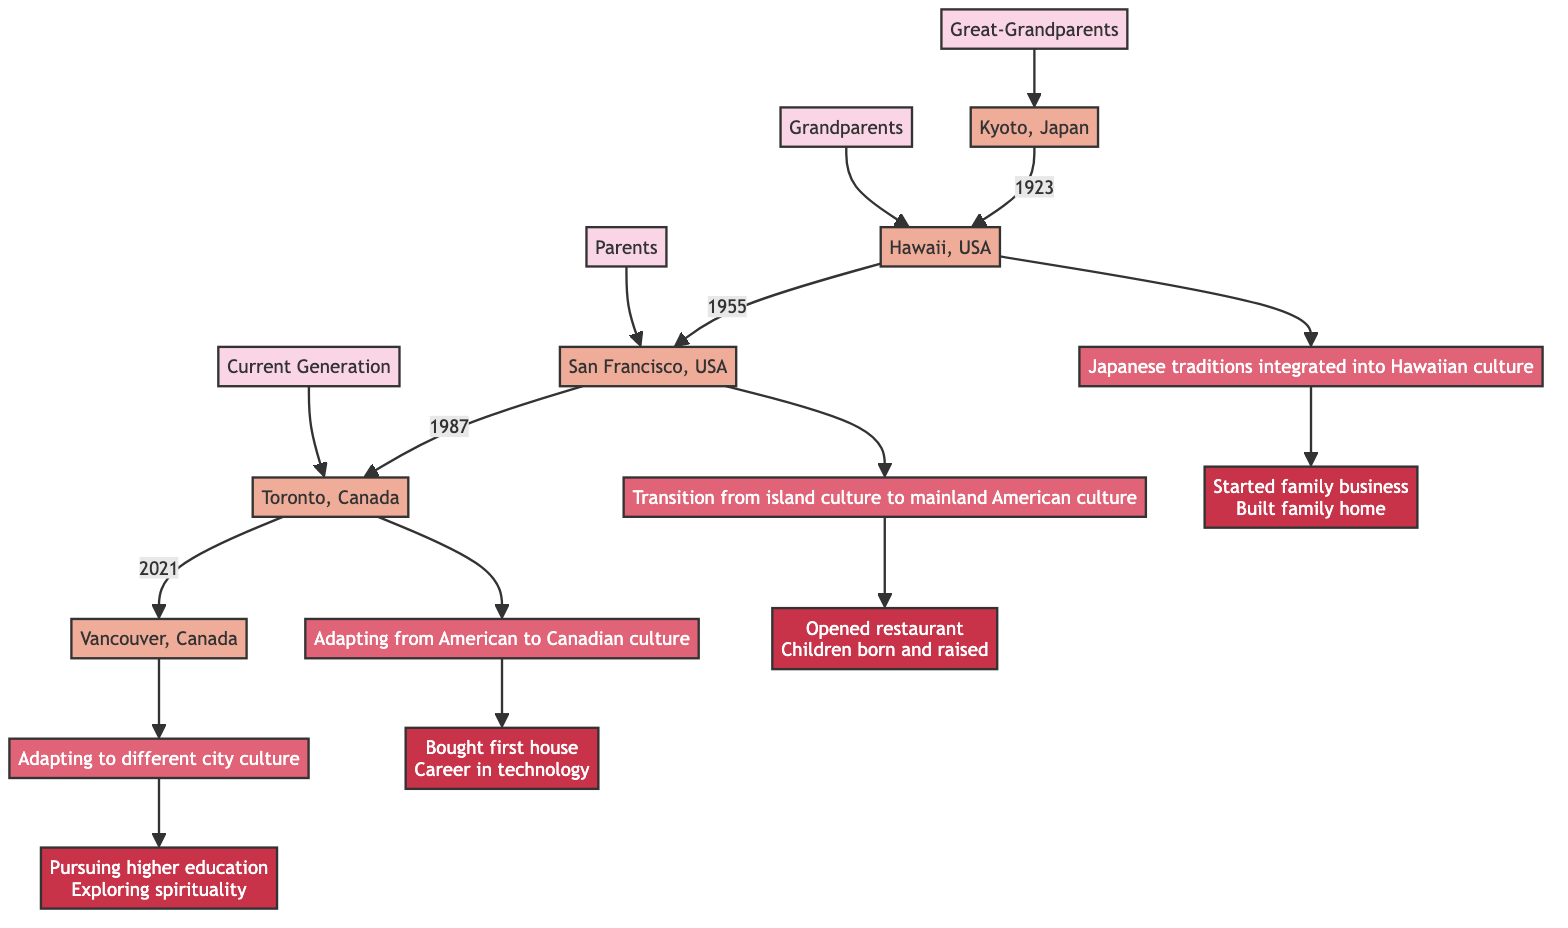What year did the Great-Grandparents migrate? The diagram shows that the Great-Grandparents migrated in 1923. This is directly linked from their migration path.
Answer: 1923 What location pairs do the Grandparents migrate between? Referring to the migration path of the Grandparents, they moved from Hawaii, USA to San Francisco, USA. This connection is found in the diagram.
Answer: Hawaii, USA to San Francisco, USA How many cultural transitions are shown for the Parents' generation? The diagram indicates that the Parents experienced one cultural transition as they moved from San Francisco to Toronto, which is described as adapting from American to Canadian culture.
Answer: 1 What is the last personal milestone mentioned for the Current Generation? Analyzing the personal milestones listed in the Current Generation's section, it shows "Exploring personal spirituality and cultural heritage" as the last milestone.
Answer: Exploring personal spirituality and cultural heritage What are the first two milestones achieved by the Great-Grandparents? The milestones associated with the Great-Grandparents describe that they started a family business and built the family home. These milestones can be extracted directly from their section in the diagram.
Answer: Started a family business, Built the family home What cultural transition is associated with the Grandparents' move? According to the diagram, the cultural transition associated with the Grandparents' migration is the transition from island culture to mainland American culture. This detail can be directly referenced from their migration path.
Answer: Transition from island culture to mainland American culture Which generation saw a migration between cities within Canada? The Current Generation is noted for moving within Canada, specifically from Toronto to Vancouver. This information can be gathered from examining their migration path in the diagram.
Answer: Current Generation How many generations moved to the USA? By reviewing the migration data, it is clear that both the Great-Grandparents and the Grandparents moved to the USA, resulting in a total of two generations moving to the USA.
Answer: 2 